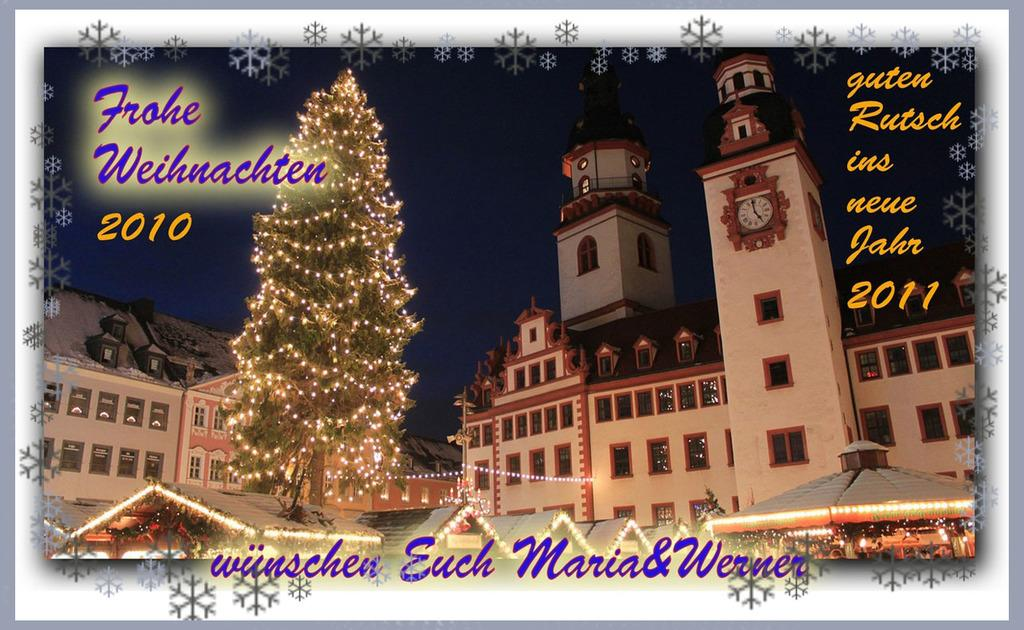What type of structures can be seen in the image? There are buildings in the image. What is the decorative element near the buildings? There is a decorated tree in the image. Is there any text or writing in the image? Yes, there is something written besides and below the tree. What type of sail can be seen on the crib in the image? There is no sail or crib present in the image. 